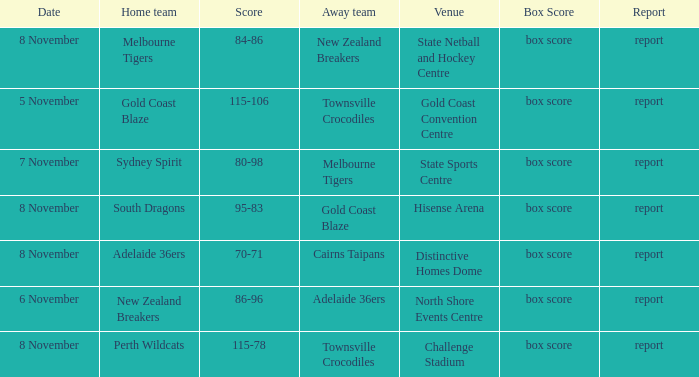What was the box score during a game that had a score of 86-96? Box score. 